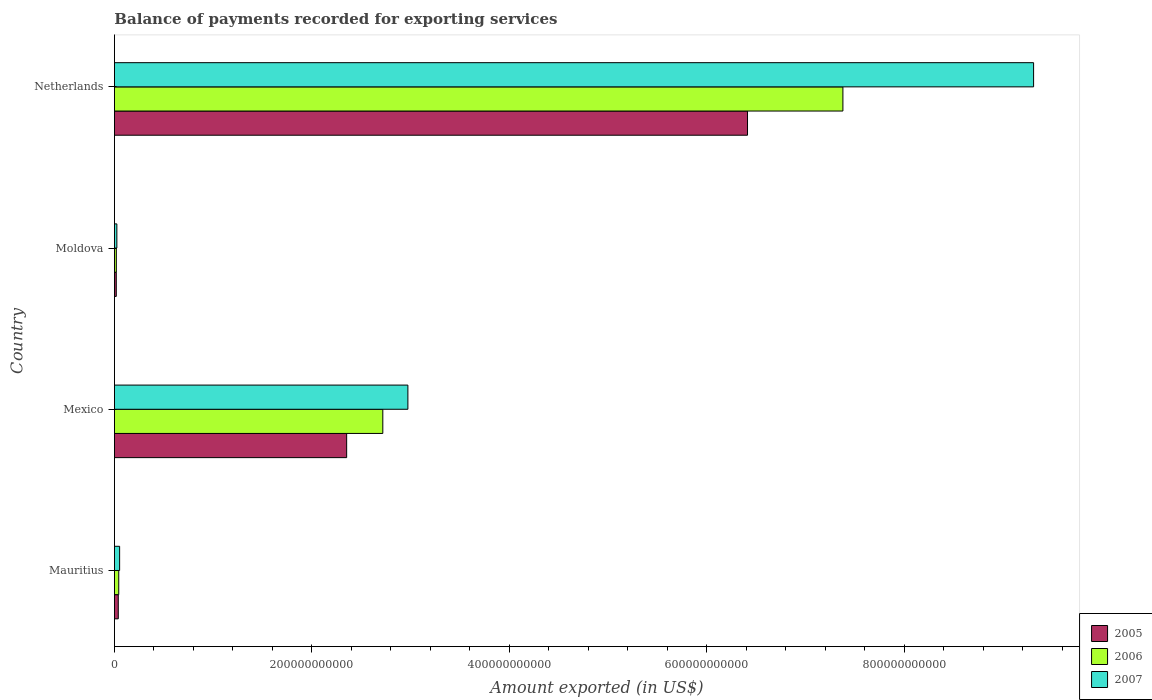How many groups of bars are there?
Provide a short and direct response. 4. Are the number of bars per tick equal to the number of legend labels?
Provide a short and direct response. Yes. How many bars are there on the 4th tick from the top?
Provide a succinct answer. 3. How many bars are there on the 4th tick from the bottom?
Give a very brief answer. 3. What is the label of the 2nd group of bars from the top?
Offer a very short reply. Moldova. In how many cases, is the number of bars for a given country not equal to the number of legend labels?
Offer a terse response. 0. What is the amount exported in 2005 in Moldova?
Provide a short and direct response. 1.87e+09. Across all countries, what is the maximum amount exported in 2006?
Your response must be concise. 7.38e+11. Across all countries, what is the minimum amount exported in 2006?
Your answer should be very brief. 1.93e+09. In which country was the amount exported in 2006 minimum?
Offer a terse response. Moldova. What is the total amount exported in 2007 in the graph?
Your answer should be very brief. 1.24e+12. What is the difference between the amount exported in 2005 in Moldova and that in Netherlands?
Offer a very short reply. -6.39e+11. What is the difference between the amount exported in 2007 in Moldova and the amount exported in 2006 in Netherlands?
Provide a succinct answer. -7.35e+11. What is the average amount exported in 2005 per country?
Offer a very short reply. 2.21e+11. What is the difference between the amount exported in 2006 and amount exported in 2007 in Netherlands?
Your response must be concise. -1.93e+11. What is the ratio of the amount exported in 2005 in Mauritius to that in Netherlands?
Your answer should be very brief. 0.01. What is the difference between the highest and the second highest amount exported in 2007?
Give a very brief answer. 6.34e+11. What is the difference between the highest and the lowest amount exported in 2006?
Offer a terse response. 7.36e+11. Is the sum of the amount exported in 2005 in Mauritius and Mexico greater than the maximum amount exported in 2007 across all countries?
Keep it short and to the point. No. What does the 3rd bar from the bottom in Mauritius represents?
Offer a very short reply. 2007. What is the difference between two consecutive major ticks on the X-axis?
Provide a succinct answer. 2.00e+11. Does the graph contain grids?
Offer a very short reply. No. Where does the legend appear in the graph?
Provide a short and direct response. Bottom right. What is the title of the graph?
Ensure brevity in your answer.  Balance of payments recorded for exporting services. Does "1994" appear as one of the legend labels in the graph?
Your answer should be very brief. No. What is the label or title of the X-axis?
Your answer should be very brief. Amount exported (in US$). What is the Amount exported (in US$) of 2005 in Mauritius?
Ensure brevity in your answer.  3.90e+09. What is the Amount exported (in US$) in 2006 in Mauritius?
Make the answer very short. 4.37e+09. What is the Amount exported (in US$) in 2007 in Mauritius?
Your answer should be compact. 5.26e+09. What is the Amount exported (in US$) in 2005 in Mexico?
Your answer should be compact. 2.35e+11. What is the Amount exported (in US$) in 2006 in Mexico?
Offer a terse response. 2.72e+11. What is the Amount exported (in US$) in 2007 in Mexico?
Your answer should be compact. 2.97e+11. What is the Amount exported (in US$) of 2005 in Moldova?
Keep it short and to the point. 1.87e+09. What is the Amount exported (in US$) of 2006 in Moldova?
Your response must be concise. 1.93e+09. What is the Amount exported (in US$) in 2007 in Moldova?
Offer a terse response. 2.46e+09. What is the Amount exported (in US$) of 2005 in Netherlands?
Make the answer very short. 6.41e+11. What is the Amount exported (in US$) in 2006 in Netherlands?
Your answer should be very brief. 7.38e+11. What is the Amount exported (in US$) in 2007 in Netherlands?
Your answer should be very brief. 9.31e+11. Across all countries, what is the maximum Amount exported (in US$) of 2005?
Your response must be concise. 6.41e+11. Across all countries, what is the maximum Amount exported (in US$) of 2006?
Offer a very short reply. 7.38e+11. Across all countries, what is the maximum Amount exported (in US$) in 2007?
Your answer should be very brief. 9.31e+11. Across all countries, what is the minimum Amount exported (in US$) in 2005?
Ensure brevity in your answer.  1.87e+09. Across all countries, what is the minimum Amount exported (in US$) of 2006?
Your answer should be very brief. 1.93e+09. Across all countries, what is the minimum Amount exported (in US$) of 2007?
Keep it short and to the point. 2.46e+09. What is the total Amount exported (in US$) in 2005 in the graph?
Keep it short and to the point. 8.82e+11. What is the total Amount exported (in US$) of 2006 in the graph?
Your answer should be very brief. 1.02e+12. What is the total Amount exported (in US$) of 2007 in the graph?
Make the answer very short. 1.24e+12. What is the difference between the Amount exported (in US$) in 2005 in Mauritius and that in Mexico?
Offer a very short reply. -2.31e+11. What is the difference between the Amount exported (in US$) in 2006 in Mauritius and that in Mexico?
Give a very brief answer. -2.67e+11. What is the difference between the Amount exported (in US$) in 2007 in Mauritius and that in Mexico?
Provide a succinct answer. -2.92e+11. What is the difference between the Amount exported (in US$) in 2005 in Mauritius and that in Moldova?
Your answer should be very brief. 2.03e+09. What is the difference between the Amount exported (in US$) of 2006 in Mauritius and that in Moldova?
Ensure brevity in your answer.  2.45e+09. What is the difference between the Amount exported (in US$) of 2007 in Mauritius and that in Moldova?
Your answer should be very brief. 2.80e+09. What is the difference between the Amount exported (in US$) of 2005 in Mauritius and that in Netherlands?
Provide a short and direct response. -6.37e+11. What is the difference between the Amount exported (in US$) in 2006 in Mauritius and that in Netherlands?
Offer a terse response. -7.33e+11. What is the difference between the Amount exported (in US$) in 2007 in Mauritius and that in Netherlands?
Your response must be concise. -9.26e+11. What is the difference between the Amount exported (in US$) in 2005 in Mexico and that in Moldova?
Offer a terse response. 2.33e+11. What is the difference between the Amount exported (in US$) of 2006 in Mexico and that in Moldova?
Your response must be concise. 2.70e+11. What is the difference between the Amount exported (in US$) of 2007 in Mexico and that in Moldova?
Make the answer very short. 2.95e+11. What is the difference between the Amount exported (in US$) in 2005 in Mexico and that in Netherlands?
Provide a short and direct response. -4.06e+11. What is the difference between the Amount exported (in US$) of 2006 in Mexico and that in Netherlands?
Give a very brief answer. -4.66e+11. What is the difference between the Amount exported (in US$) in 2007 in Mexico and that in Netherlands?
Make the answer very short. -6.34e+11. What is the difference between the Amount exported (in US$) in 2005 in Moldova and that in Netherlands?
Your response must be concise. -6.39e+11. What is the difference between the Amount exported (in US$) of 2006 in Moldova and that in Netherlands?
Your response must be concise. -7.36e+11. What is the difference between the Amount exported (in US$) of 2007 in Moldova and that in Netherlands?
Keep it short and to the point. -9.28e+11. What is the difference between the Amount exported (in US$) in 2005 in Mauritius and the Amount exported (in US$) in 2006 in Mexico?
Keep it short and to the point. -2.68e+11. What is the difference between the Amount exported (in US$) of 2005 in Mauritius and the Amount exported (in US$) of 2007 in Mexico?
Provide a succinct answer. -2.93e+11. What is the difference between the Amount exported (in US$) of 2006 in Mauritius and the Amount exported (in US$) of 2007 in Mexico?
Your response must be concise. -2.93e+11. What is the difference between the Amount exported (in US$) of 2005 in Mauritius and the Amount exported (in US$) of 2006 in Moldova?
Your answer should be compact. 1.97e+09. What is the difference between the Amount exported (in US$) of 2005 in Mauritius and the Amount exported (in US$) of 2007 in Moldova?
Keep it short and to the point. 1.44e+09. What is the difference between the Amount exported (in US$) in 2006 in Mauritius and the Amount exported (in US$) in 2007 in Moldova?
Your answer should be compact. 1.92e+09. What is the difference between the Amount exported (in US$) of 2005 in Mauritius and the Amount exported (in US$) of 2006 in Netherlands?
Provide a succinct answer. -7.34e+11. What is the difference between the Amount exported (in US$) in 2005 in Mauritius and the Amount exported (in US$) in 2007 in Netherlands?
Offer a terse response. -9.27e+11. What is the difference between the Amount exported (in US$) of 2006 in Mauritius and the Amount exported (in US$) of 2007 in Netherlands?
Offer a terse response. -9.27e+11. What is the difference between the Amount exported (in US$) of 2005 in Mexico and the Amount exported (in US$) of 2006 in Moldova?
Give a very brief answer. 2.33e+11. What is the difference between the Amount exported (in US$) in 2005 in Mexico and the Amount exported (in US$) in 2007 in Moldova?
Keep it short and to the point. 2.33e+11. What is the difference between the Amount exported (in US$) of 2006 in Mexico and the Amount exported (in US$) of 2007 in Moldova?
Your answer should be compact. 2.69e+11. What is the difference between the Amount exported (in US$) of 2005 in Mexico and the Amount exported (in US$) of 2006 in Netherlands?
Keep it short and to the point. -5.03e+11. What is the difference between the Amount exported (in US$) of 2005 in Mexico and the Amount exported (in US$) of 2007 in Netherlands?
Keep it short and to the point. -6.96e+11. What is the difference between the Amount exported (in US$) in 2006 in Mexico and the Amount exported (in US$) in 2007 in Netherlands?
Your answer should be very brief. -6.59e+11. What is the difference between the Amount exported (in US$) in 2005 in Moldova and the Amount exported (in US$) in 2006 in Netherlands?
Provide a succinct answer. -7.36e+11. What is the difference between the Amount exported (in US$) of 2005 in Moldova and the Amount exported (in US$) of 2007 in Netherlands?
Make the answer very short. -9.29e+11. What is the difference between the Amount exported (in US$) in 2006 in Moldova and the Amount exported (in US$) in 2007 in Netherlands?
Ensure brevity in your answer.  -9.29e+11. What is the average Amount exported (in US$) in 2005 per country?
Ensure brevity in your answer.  2.21e+11. What is the average Amount exported (in US$) of 2006 per country?
Keep it short and to the point. 2.54e+11. What is the average Amount exported (in US$) of 2007 per country?
Your answer should be very brief. 3.09e+11. What is the difference between the Amount exported (in US$) in 2005 and Amount exported (in US$) in 2006 in Mauritius?
Give a very brief answer. -4.75e+08. What is the difference between the Amount exported (in US$) in 2005 and Amount exported (in US$) in 2007 in Mauritius?
Give a very brief answer. -1.36e+09. What is the difference between the Amount exported (in US$) in 2006 and Amount exported (in US$) in 2007 in Mauritius?
Provide a short and direct response. -8.85e+08. What is the difference between the Amount exported (in US$) in 2005 and Amount exported (in US$) in 2006 in Mexico?
Offer a terse response. -3.66e+1. What is the difference between the Amount exported (in US$) of 2005 and Amount exported (in US$) of 2007 in Mexico?
Your answer should be compact. -6.20e+1. What is the difference between the Amount exported (in US$) of 2006 and Amount exported (in US$) of 2007 in Mexico?
Your response must be concise. -2.54e+1. What is the difference between the Amount exported (in US$) in 2005 and Amount exported (in US$) in 2006 in Moldova?
Ensure brevity in your answer.  -5.65e+07. What is the difference between the Amount exported (in US$) of 2005 and Amount exported (in US$) of 2007 in Moldova?
Provide a short and direct response. -5.84e+08. What is the difference between the Amount exported (in US$) in 2006 and Amount exported (in US$) in 2007 in Moldova?
Your answer should be very brief. -5.28e+08. What is the difference between the Amount exported (in US$) of 2005 and Amount exported (in US$) of 2006 in Netherlands?
Provide a succinct answer. -9.66e+1. What is the difference between the Amount exported (in US$) of 2005 and Amount exported (in US$) of 2007 in Netherlands?
Offer a very short reply. -2.90e+11. What is the difference between the Amount exported (in US$) of 2006 and Amount exported (in US$) of 2007 in Netherlands?
Your answer should be very brief. -1.93e+11. What is the ratio of the Amount exported (in US$) of 2005 in Mauritius to that in Mexico?
Offer a very short reply. 0.02. What is the ratio of the Amount exported (in US$) in 2006 in Mauritius to that in Mexico?
Provide a short and direct response. 0.02. What is the ratio of the Amount exported (in US$) in 2007 in Mauritius to that in Mexico?
Your response must be concise. 0.02. What is the ratio of the Amount exported (in US$) of 2005 in Mauritius to that in Moldova?
Your answer should be very brief. 2.08. What is the ratio of the Amount exported (in US$) of 2006 in Mauritius to that in Moldova?
Your answer should be compact. 2.27. What is the ratio of the Amount exported (in US$) in 2007 in Mauritius to that in Moldova?
Your answer should be very brief. 2.14. What is the ratio of the Amount exported (in US$) in 2005 in Mauritius to that in Netherlands?
Provide a short and direct response. 0.01. What is the ratio of the Amount exported (in US$) of 2006 in Mauritius to that in Netherlands?
Offer a very short reply. 0.01. What is the ratio of the Amount exported (in US$) in 2007 in Mauritius to that in Netherlands?
Make the answer very short. 0.01. What is the ratio of the Amount exported (in US$) in 2005 in Mexico to that in Moldova?
Offer a terse response. 125.67. What is the ratio of the Amount exported (in US$) of 2006 in Mexico to that in Moldova?
Offer a very short reply. 140.98. What is the ratio of the Amount exported (in US$) in 2007 in Mexico to that in Moldova?
Ensure brevity in your answer.  121.03. What is the ratio of the Amount exported (in US$) in 2005 in Mexico to that in Netherlands?
Provide a succinct answer. 0.37. What is the ratio of the Amount exported (in US$) in 2006 in Mexico to that in Netherlands?
Ensure brevity in your answer.  0.37. What is the ratio of the Amount exported (in US$) of 2007 in Mexico to that in Netherlands?
Your answer should be compact. 0.32. What is the ratio of the Amount exported (in US$) in 2005 in Moldova to that in Netherlands?
Make the answer very short. 0. What is the ratio of the Amount exported (in US$) of 2006 in Moldova to that in Netherlands?
Provide a succinct answer. 0. What is the ratio of the Amount exported (in US$) of 2007 in Moldova to that in Netherlands?
Ensure brevity in your answer.  0. What is the difference between the highest and the second highest Amount exported (in US$) in 2005?
Offer a terse response. 4.06e+11. What is the difference between the highest and the second highest Amount exported (in US$) of 2006?
Provide a short and direct response. 4.66e+11. What is the difference between the highest and the second highest Amount exported (in US$) in 2007?
Your response must be concise. 6.34e+11. What is the difference between the highest and the lowest Amount exported (in US$) in 2005?
Provide a short and direct response. 6.39e+11. What is the difference between the highest and the lowest Amount exported (in US$) in 2006?
Ensure brevity in your answer.  7.36e+11. What is the difference between the highest and the lowest Amount exported (in US$) in 2007?
Offer a terse response. 9.28e+11. 